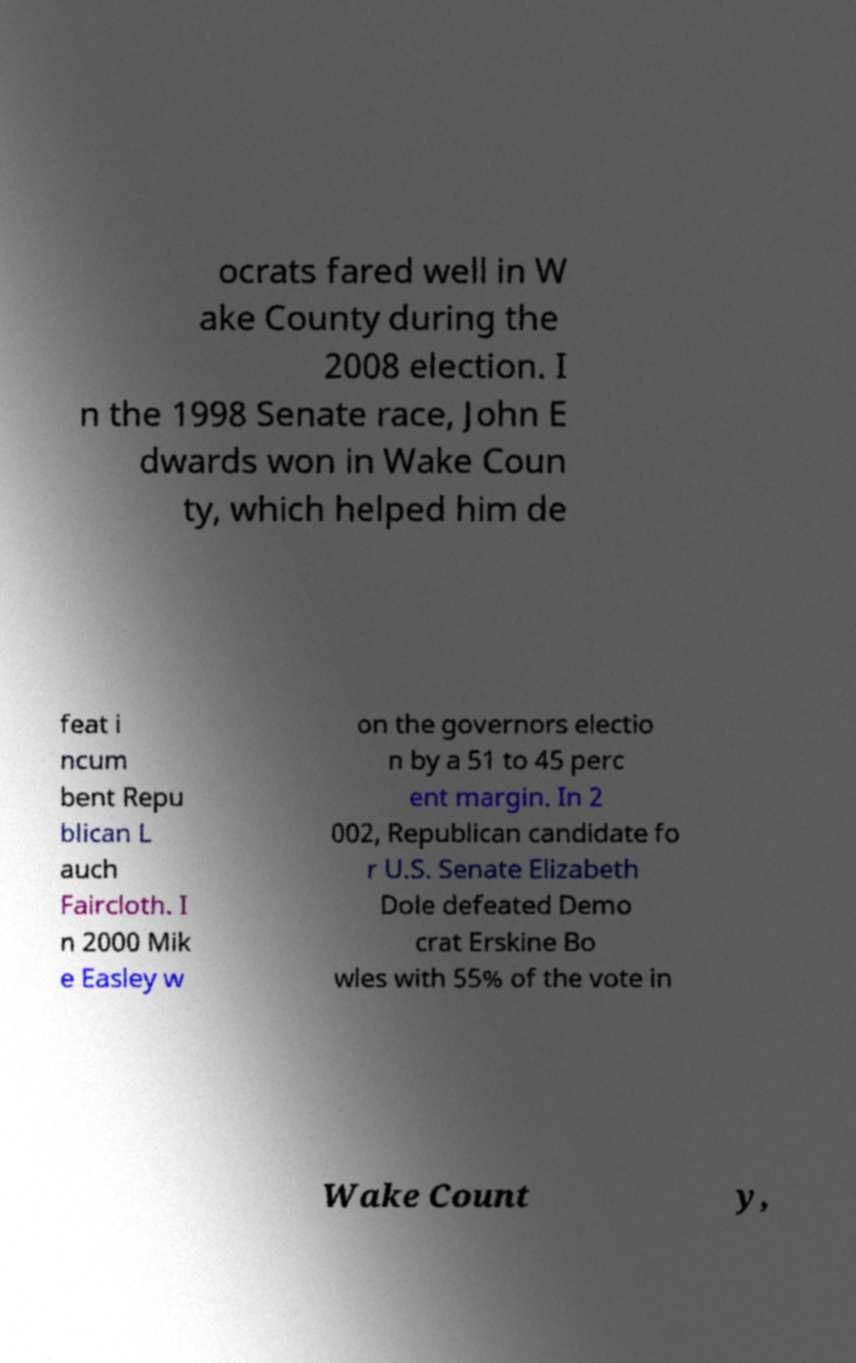There's text embedded in this image that I need extracted. Can you transcribe it verbatim? ocrats fared well in W ake County during the 2008 election. I n the 1998 Senate race, John E dwards won in Wake Coun ty, which helped him de feat i ncum bent Repu blican L auch Faircloth. I n 2000 Mik e Easley w on the governors electio n by a 51 to 45 perc ent margin. In 2 002, Republican candidate fo r U.S. Senate Elizabeth Dole defeated Demo crat Erskine Bo wles with 55% of the vote in Wake Count y, 